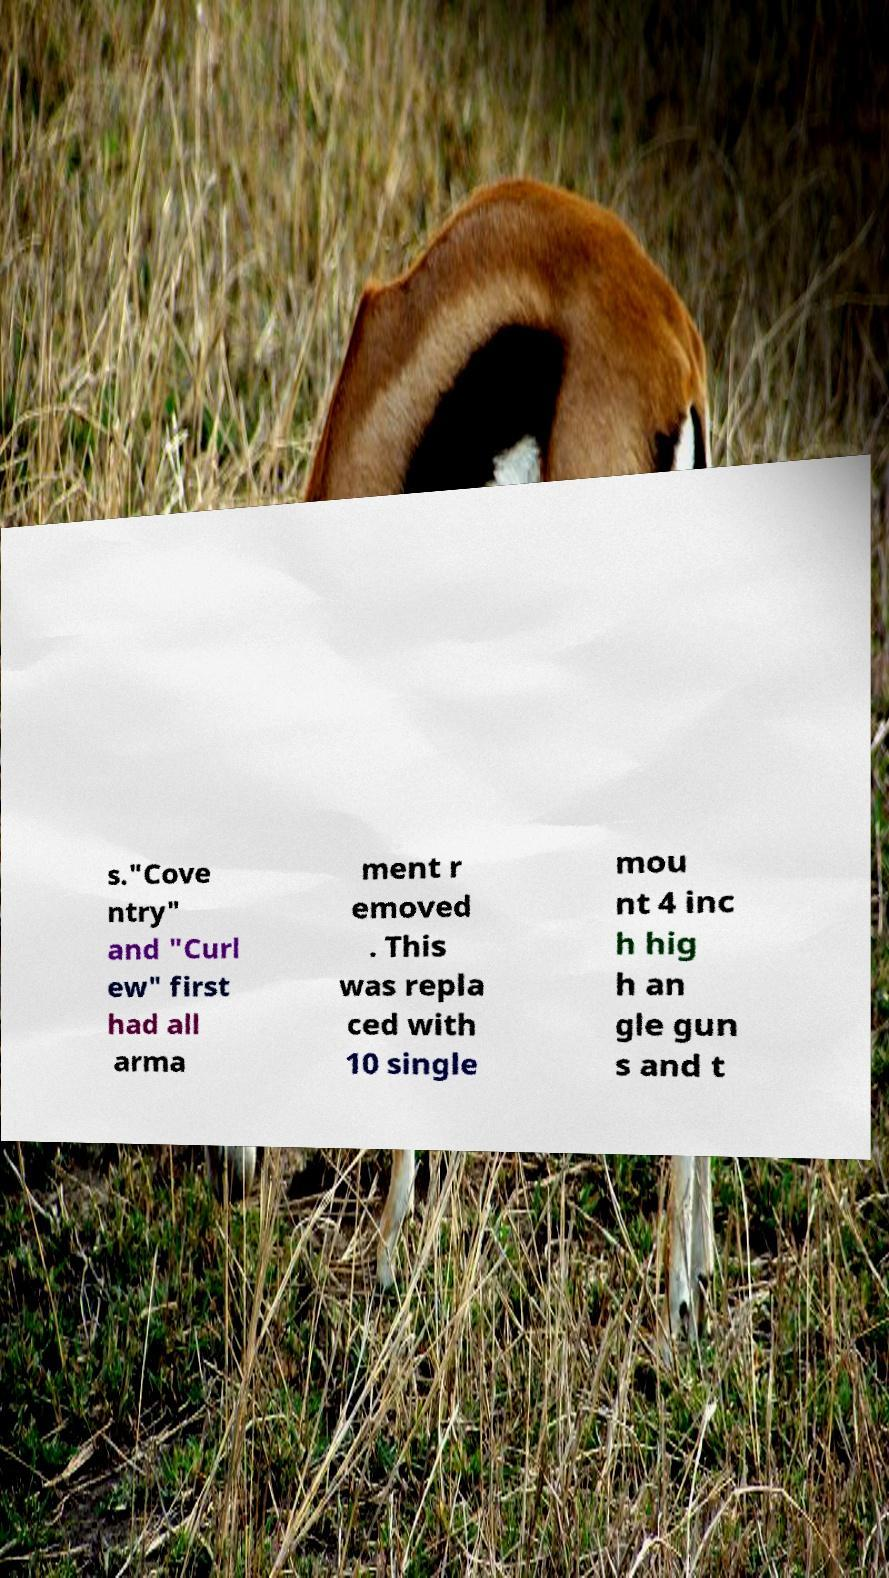Please identify and transcribe the text found in this image. s."Cove ntry" and "Curl ew" first had all arma ment r emoved . This was repla ced with 10 single mou nt 4 inc h hig h an gle gun s and t 